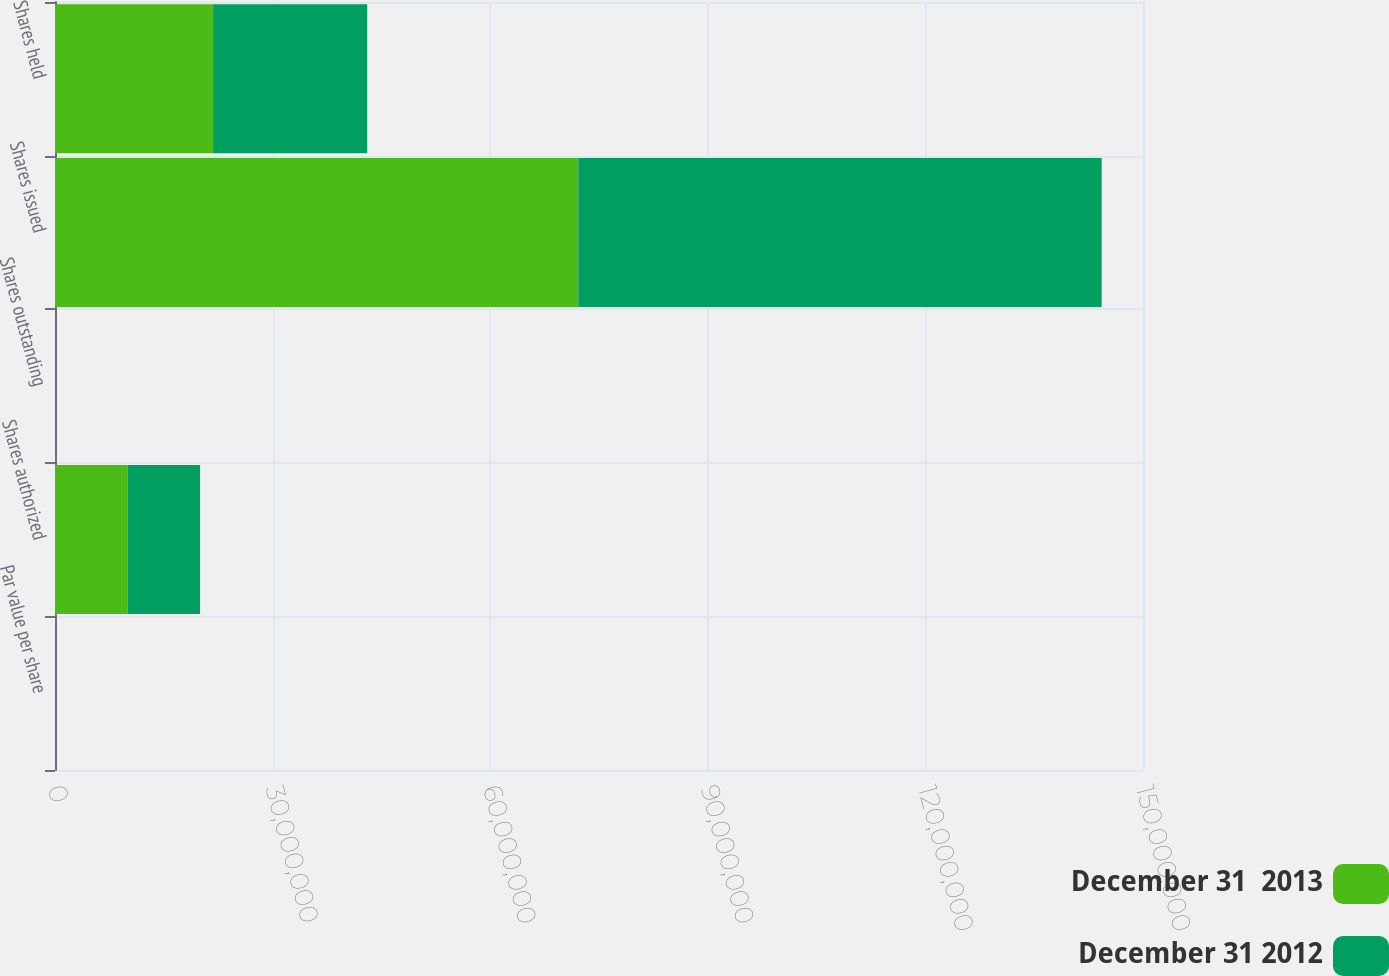Convert chart. <chart><loc_0><loc_0><loc_500><loc_500><stacked_bar_chart><ecel><fcel>Par value per share<fcel>Shares authorized<fcel>Shares outstanding<fcel>Shares issued<fcel>Shares held<nl><fcel>December 31  2013<fcel>0.01<fcel>1e+07<fcel>0<fcel>7.21519e+07<fcel>2.18023e+07<nl><fcel>December 31 2012<fcel>0.01<fcel>1e+07<fcel>0<fcel>7.21519e+07<fcel>2.12436e+07<nl></chart> 